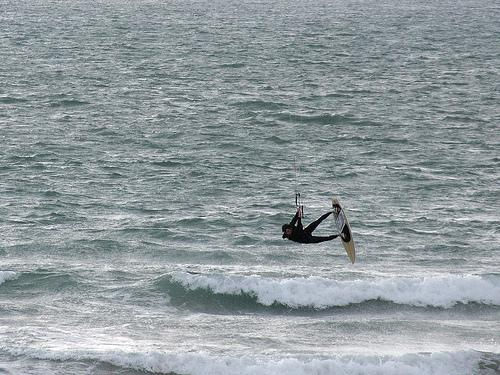Describe the ocean's appearance and the human subject's interaction with it. The ocean has calm and white-capped waves, while a man wearing a black wet suit kite surfs on his surfboard. Mention the primary focus of the image, along with the color and detail of the water and waves. A person wind surfing on foamy white and green ocean waves, with the crest of the wave being white. Briefly explain the action taking place in the image and describe any notable elements. A man wearing a black wetsuit and attached to a white surfboard through foot straps, performs kite surfing amidst ocean waves. Give a concise description of the picture, featuring the person kite surfing and the water surface. A kite surfer in a black wetsuit navigates his white surfboard atop foamy white and green ocean waves. Narrate the scene captured in the photograph, focusing on the person and their equipment. In the image, a man in a black wetsuit kite surfs using a handle and a white board, while looking down at the water. Illustrate the main scene being displayed in the image, featuring the person and the environment. A young man in a black wetsuit is kite surfing in the air on a yellow surfboard, amidst foamy white ocean waves. Explain what the person is doing in the image, and describe their attire and equipment. A man wearing a black wet suit is para sailing on a kite surf board, holding onto the handle with both hands. Tell about the person's attire and focused activity, as well as the surrounding environment in the image. A man dressed in a black wetsuit is airborne and kite surfing on ocean waves with white caps crashing down. Provide a brief description of the person and their activity in the image. A young man is kite surfing, wearing a black wetsuit and attached to a white surfboard. Discuss the person's activity in the photograph and emphasize the equipment they are using. A man kite surfing uses a white kite board and a handle that connects him to the sail, while wearing a black wet suit. 